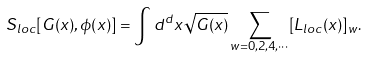Convert formula to latex. <formula><loc_0><loc_0><loc_500><loc_500>S _ { l o c } [ G ( x ) , \phi ( x ) ] = \int d ^ { d } x \sqrt { G ( x ) } \sum _ { w = 0 , 2 , 4 , \cdots } [ L _ { l o c } ( x ) ] _ { w } .</formula> 